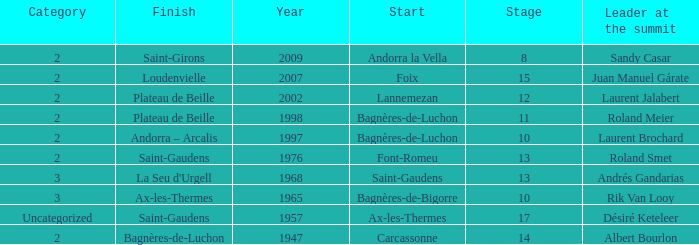Give the Finish for a Stage that is larger than 15 Saint-Gaudens. 